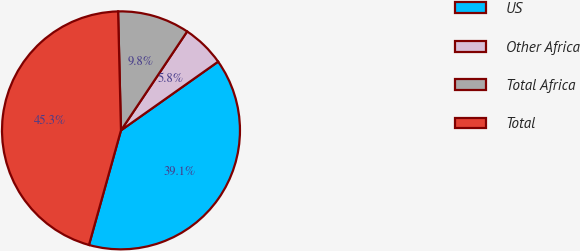Convert chart to OTSL. <chart><loc_0><loc_0><loc_500><loc_500><pie_chart><fcel>US<fcel>Other Africa<fcel>Total Africa<fcel>Total<nl><fcel>39.13%<fcel>5.82%<fcel>9.77%<fcel>45.28%<nl></chart> 